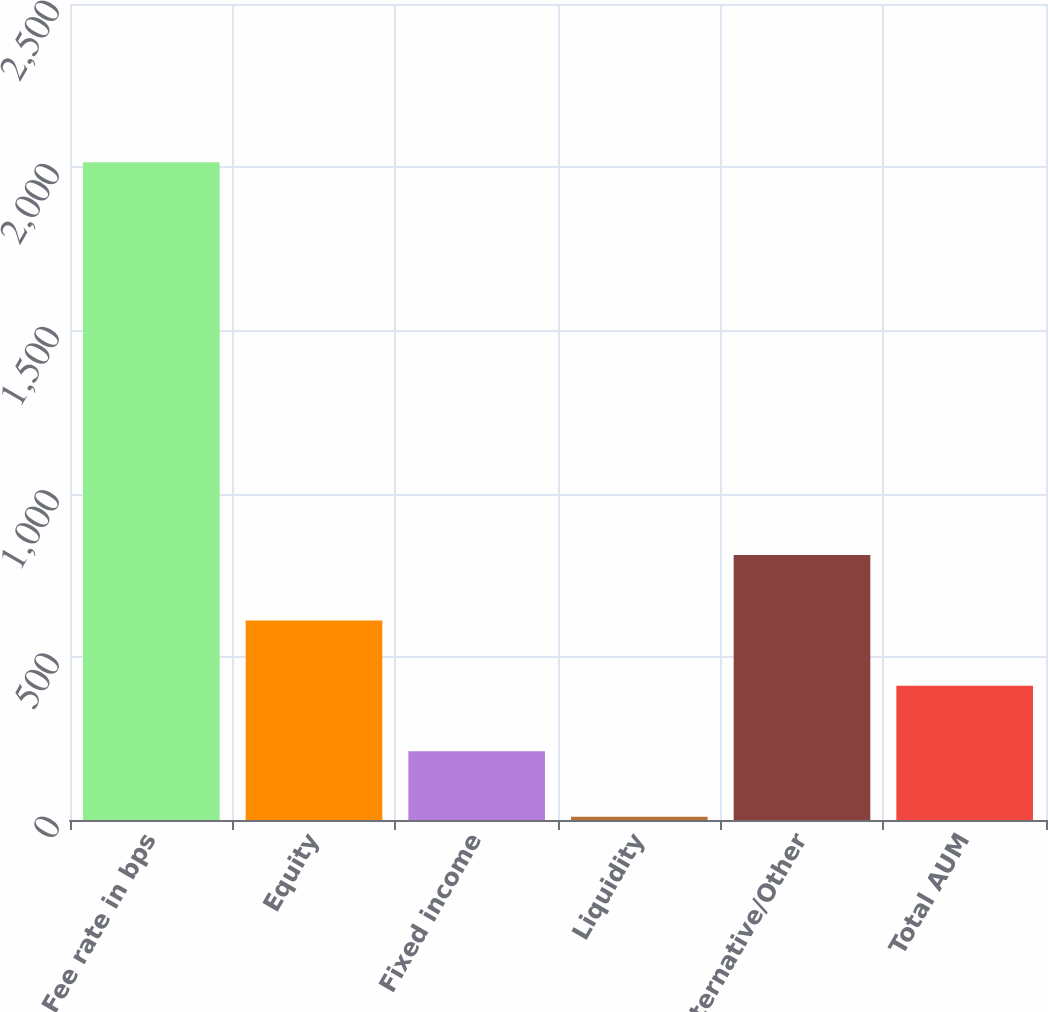Convert chart. <chart><loc_0><loc_0><loc_500><loc_500><bar_chart><fcel>Fee rate in bps<fcel>Equity<fcel>Fixed income<fcel>Liquidity<fcel>Alternative/Other<fcel>Total AUM<nl><fcel>2015<fcel>611.5<fcel>210.5<fcel>10<fcel>812<fcel>411<nl></chart> 